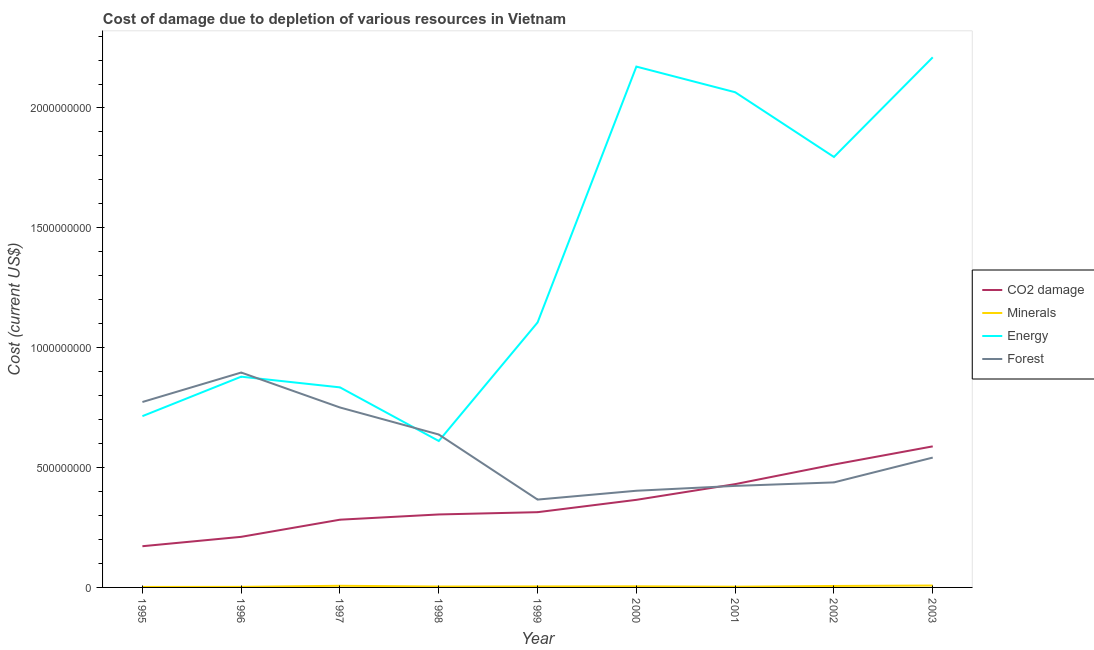How many different coloured lines are there?
Keep it short and to the point. 4. What is the cost of damage due to depletion of coal in 1999?
Offer a terse response. 3.14e+08. Across all years, what is the maximum cost of damage due to depletion of coal?
Your answer should be compact. 5.88e+08. Across all years, what is the minimum cost of damage due to depletion of forests?
Offer a very short reply. 3.66e+08. What is the total cost of damage due to depletion of energy in the graph?
Offer a very short reply. 1.24e+1. What is the difference between the cost of damage due to depletion of coal in 1996 and that in 1997?
Offer a terse response. -7.15e+07. What is the difference between the cost of damage due to depletion of forests in 1999 and the cost of damage due to depletion of energy in 2003?
Your answer should be compact. -1.84e+09. What is the average cost of damage due to depletion of forests per year?
Your answer should be compact. 5.81e+08. In the year 2003, what is the difference between the cost of damage due to depletion of minerals and cost of damage due to depletion of forests?
Your answer should be compact. -5.34e+08. In how many years, is the cost of damage due to depletion of coal greater than 800000000 US$?
Your answer should be very brief. 0. What is the ratio of the cost of damage due to depletion of coal in 2000 to that in 2001?
Keep it short and to the point. 0.85. What is the difference between the highest and the second highest cost of damage due to depletion of energy?
Offer a very short reply. 3.87e+07. What is the difference between the highest and the lowest cost of damage due to depletion of coal?
Ensure brevity in your answer.  4.17e+08. In how many years, is the cost of damage due to depletion of forests greater than the average cost of damage due to depletion of forests taken over all years?
Provide a succinct answer. 4. Is it the case that in every year, the sum of the cost of damage due to depletion of coal and cost of damage due to depletion of minerals is greater than the sum of cost of damage due to depletion of forests and cost of damage due to depletion of energy?
Your answer should be compact. No. Is the cost of damage due to depletion of forests strictly less than the cost of damage due to depletion of energy over the years?
Your answer should be very brief. No. How many lines are there?
Offer a terse response. 4. How many years are there in the graph?
Give a very brief answer. 9. What is the difference between two consecutive major ticks on the Y-axis?
Provide a short and direct response. 5.00e+08. How many legend labels are there?
Offer a terse response. 4. What is the title of the graph?
Ensure brevity in your answer.  Cost of damage due to depletion of various resources in Vietnam . What is the label or title of the Y-axis?
Give a very brief answer. Cost (current US$). What is the Cost (current US$) in CO2 damage in 1995?
Ensure brevity in your answer.  1.72e+08. What is the Cost (current US$) of Minerals in 1995?
Offer a terse response. 2.01e+06. What is the Cost (current US$) in Energy in 1995?
Offer a very short reply. 7.15e+08. What is the Cost (current US$) of Forest in 1995?
Give a very brief answer. 7.74e+08. What is the Cost (current US$) of CO2 damage in 1996?
Your answer should be compact. 2.11e+08. What is the Cost (current US$) in Minerals in 1996?
Provide a succinct answer. 2.35e+06. What is the Cost (current US$) of Energy in 1996?
Your response must be concise. 8.79e+08. What is the Cost (current US$) of Forest in 1996?
Your answer should be very brief. 8.96e+08. What is the Cost (current US$) in CO2 damage in 1997?
Offer a terse response. 2.83e+08. What is the Cost (current US$) of Minerals in 1997?
Ensure brevity in your answer.  6.86e+06. What is the Cost (current US$) of Energy in 1997?
Offer a terse response. 8.35e+08. What is the Cost (current US$) in Forest in 1997?
Keep it short and to the point. 7.51e+08. What is the Cost (current US$) of CO2 damage in 1998?
Offer a terse response. 3.04e+08. What is the Cost (current US$) in Minerals in 1998?
Your answer should be compact. 3.69e+06. What is the Cost (current US$) of Energy in 1998?
Offer a terse response. 6.11e+08. What is the Cost (current US$) in Forest in 1998?
Ensure brevity in your answer.  6.38e+08. What is the Cost (current US$) of CO2 damage in 1999?
Provide a short and direct response. 3.14e+08. What is the Cost (current US$) in Minerals in 1999?
Give a very brief answer. 4.13e+06. What is the Cost (current US$) of Energy in 1999?
Provide a short and direct response. 1.11e+09. What is the Cost (current US$) of Forest in 1999?
Your answer should be compact. 3.66e+08. What is the Cost (current US$) in CO2 damage in 2000?
Your answer should be compact. 3.65e+08. What is the Cost (current US$) of Minerals in 2000?
Your answer should be compact. 4.61e+06. What is the Cost (current US$) of Energy in 2000?
Provide a short and direct response. 2.17e+09. What is the Cost (current US$) of Forest in 2000?
Provide a short and direct response. 4.03e+08. What is the Cost (current US$) of CO2 damage in 2001?
Offer a terse response. 4.31e+08. What is the Cost (current US$) in Minerals in 2001?
Give a very brief answer. 3.05e+06. What is the Cost (current US$) in Energy in 2001?
Your answer should be compact. 2.07e+09. What is the Cost (current US$) in Forest in 2001?
Your response must be concise. 4.24e+08. What is the Cost (current US$) of CO2 damage in 2002?
Offer a terse response. 5.13e+08. What is the Cost (current US$) in Minerals in 2002?
Give a very brief answer. 6.10e+06. What is the Cost (current US$) in Energy in 2002?
Make the answer very short. 1.80e+09. What is the Cost (current US$) in Forest in 2002?
Provide a succinct answer. 4.38e+08. What is the Cost (current US$) in CO2 damage in 2003?
Your answer should be very brief. 5.88e+08. What is the Cost (current US$) of Minerals in 2003?
Your answer should be very brief. 7.88e+06. What is the Cost (current US$) in Energy in 2003?
Give a very brief answer. 2.21e+09. What is the Cost (current US$) of Forest in 2003?
Provide a short and direct response. 5.42e+08. Across all years, what is the maximum Cost (current US$) in CO2 damage?
Your response must be concise. 5.88e+08. Across all years, what is the maximum Cost (current US$) of Minerals?
Provide a short and direct response. 7.88e+06. Across all years, what is the maximum Cost (current US$) in Energy?
Keep it short and to the point. 2.21e+09. Across all years, what is the maximum Cost (current US$) in Forest?
Offer a very short reply. 8.96e+08. Across all years, what is the minimum Cost (current US$) of CO2 damage?
Your answer should be compact. 1.72e+08. Across all years, what is the minimum Cost (current US$) in Minerals?
Provide a short and direct response. 2.01e+06. Across all years, what is the minimum Cost (current US$) of Energy?
Offer a terse response. 6.11e+08. Across all years, what is the minimum Cost (current US$) in Forest?
Provide a succinct answer. 3.66e+08. What is the total Cost (current US$) of CO2 damage in the graph?
Make the answer very short. 3.18e+09. What is the total Cost (current US$) of Minerals in the graph?
Offer a terse response. 4.07e+07. What is the total Cost (current US$) of Energy in the graph?
Provide a succinct answer. 1.24e+1. What is the total Cost (current US$) of Forest in the graph?
Your answer should be very brief. 5.23e+09. What is the difference between the Cost (current US$) of CO2 damage in 1995 and that in 1996?
Your answer should be compact. -3.92e+07. What is the difference between the Cost (current US$) in Minerals in 1995 and that in 1996?
Your answer should be very brief. -3.38e+05. What is the difference between the Cost (current US$) of Energy in 1995 and that in 1996?
Provide a succinct answer. -1.65e+08. What is the difference between the Cost (current US$) of Forest in 1995 and that in 1996?
Give a very brief answer. -1.23e+08. What is the difference between the Cost (current US$) in CO2 damage in 1995 and that in 1997?
Your answer should be compact. -1.11e+08. What is the difference between the Cost (current US$) in Minerals in 1995 and that in 1997?
Your response must be concise. -4.85e+06. What is the difference between the Cost (current US$) of Energy in 1995 and that in 1997?
Make the answer very short. -1.20e+08. What is the difference between the Cost (current US$) in Forest in 1995 and that in 1997?
Ensure brevity in your answer.  2.29e+07. What is the difference between the Cost (current US$) of CO2 damage in 1995 and that in 1998?
Offer a very short reply. -1.33e+08. What is the difference between the Cost (current US$) in Minerals in 1995 and that in 1998?
Provide a short and direct response. -1.67e+06. What is the difference between the Cost (current US$) in Energy in 1995 and that in 1998?
Your response must be concise. 1.04e+08. What is the difference between the Cost (current US$) in Forest in 1995 and that in 1998?
Your response must be concise. 1.36e+08. What is the difference between the Cost (current US$) in CO2 damage in 1995 and that in 1999?
Your answer should be very brief. -1.42e+08. What is the difference between the Cost (current US$) in Minerals in 1995 and that in 1999?
Keep it short and to the point. -2.12e+06. What is the difference between the Cost (current US$) in Energy in 1995 and that in 1999?
Give a very brief answer. -3.91e+08. What is the difference between the Cost (current US$) in Forest in 1995 and that in 1999?
Offer a terse response. 4.07e+08. What is the difference between the Cost (current US$) in CO2 damage in 1995 and that in 2000?
Ensure brevity in your answer.  -1.93e+08. What is the difference between the Cost (current US$) of Minerals in 1995 and that in 2000?
Keep it short and to the point. -2.59e+06. What is the difference between the Cost (current US$) of Energy in 1995 and that in 2000?
Offer a very short reply. -1.46e+09. What is the difference between the Cost (current US$) in Forest in 1995 and that in 2000?
Keep it short and to the point. 3.70e+08. What is the difference between the Cost (current US$) of CO2 damage in 1995 and that in 2001?
Ensure brevity in your answer.  -2.59e+08. What is the difference between the Cost (current US$) in Minerals in 1995 and that in 2001?
Your answer should be very brief. -1.03e+06. What is the difference between the Cost (current US$) in Energy in 1995 and that in 2001?
Offer a very short reply. -1.35e+09. What is the difference between the Cost (current US$) in Forest in 1995 and that in 2001?
Offer a terse response. 3.50e+08. What is the difference between the Cost (current US$) in CO2 damage in 1995 and that in 2002?
Your answer should be compact. -3.41e+08. What is the difference between the Cost (current US$) in Minerals in 1995 and that in 2002?
Provide a succinct answer. -4.08e+06. What is the difference between the Cost (current US$) of Energy in 1995 and that in 2002?
Make the answer very short. -1.08e+09. What is the difference between the Cost (current US$) in Forest in 1995 and that in 2002?
Make the answer very short. 3.35e+08. What is the difference between the Cost (current US$) in CO2 damage in 1995 and that in 2003?
Your answer should be compact. -4.17e+08. What is the difference between the Cost (current US$) of Minerals in 1995 and that in 2003?
Offer a very short reply. -5.86e+06. What is the difference between the Cost (current US$) in Energy in 1995 and that in 2003?
Your answer should be compact. -1.50e+09. What is the difference between the Cost (current US$) in Forest in 1995 and that in 2003?
Keep it short and to the point. 2.32e+08. What is the difference between the Cost (current US$) of CO2 damage in 1996 and that in 1997?
Your answer should be very brief. -7.15e+07. What is the difference between the Cost (current US$) in Minerals in 1996 and that in 1997?
Ensure brevity in your answer.  -4.51e+06. What is the difference between the Cost (current US$) of Energy in 1996 and that in 1997?
Your answer should be compact. 4.46e+07. What is the difference between the Cost (current US$) in Forest in 1996 and that in 1997?
Your answer should be compact. 1.46e+08. What is the difference between the Cost (current US$) of CO2 damage in 1996 and that in 1998?
Provide a short and direct response. -9.34e+07. What is the difference between the Cost (current US$) in Minerals in 1996 and that in 1998?
Your answer should be very brief. -1.33e+06. What is the difference between the Cost (current US$) of Energy in 1996 and that in 1998?
Your answer should be very brief. 2.68e+08. What is the difference between the Cost (current US$) of Forest in 1996 and that in 1998?
Offer a terse response. 2.59e+08. What is the difference between the Cost (current US$) in CO2 damage in 1996 and that in 1999?
Make the answer very short. -1.03e+08. What is the difference between the Cost (current US$) of Minerals in 1996 and that in 1999?
Keep it short and to the point. -1.78e+06. What is the difference between the Cost (current US$) of Energy in 1996 and that in 1999?
Provide a succinct answer. -2.26e+08. What is the difference between the Cost (current US$) of Forest in 1996 and that in 1999?
Give a very brief answer. 5.30e+08. What is the difference between the Cost (current US$) of CO2 damage in 1996 and that in 2000?
Ensure brevity in your answer.  -1.54e+08. What is the difference between the Cost (current US$) in Minerals in 1996 and that in 2000?
Make the answer very short. -2.25e+06. What is the difference between the Cost (current US$) of Energy in 1996 and that in 2000?
Offer a terse response. -1.29e+09. What is the difference between the Cost (current US$) in Forest in 1996 and that in 2000?
Give a very brief answer. 4.93e+08. What is the difference between the Cost (current US$) of CO2 damage in 1996 and that in 2001?
Provide a short and direct response. -2.20e+08. What is the difference between the Cost (current US$) in Minerals in 1996 and that in 2001?
Give a very brief answer. -6.95e+05. What is the difference between the Cost (current US$) of Energy in 1996 and that in 2001?
Your response must be concise. -1.19e+09. What is the difference between the Cost (current US$) in Forest in 1996 and that in 2001?
Your answer should be compact. 4.73e+08. What is the difference between the Cost (current US$) in CO2 damage in 1996 and that in 2002?
Ensure brevity in your answer.  -3.02e+08. What is the difference between the Cost (current US$) of Minerals in 1996 and that in 2002?
Offer a terse response. -3.75e+06. What is the difference between the Cost (current US$) of Energy in 1996 and that in 2002?
Ensure brevity in your answer.  -9.17e+08. What is the difference between the Cost (current US$) of Forest in 1996 and that in 2002?
Provide a succinct answer. 4.58e+08. What is the difference between the Cost (current US$) of CO2 damage in 1996 and that in 2003?
Offer a terse response. -3.77e+08. What is the difference between the Cost (current US$) of Minerals in 1996 and that in 2003?
Your response must be concise. -5.53e+06. What is the difference between the Cost (current US$) in Energy in 1996 and that in 2003?
Keep it short and to the point. -1.33e+09. What is the difference between the Cost (current US$) in Forest in 1996 and that in 2003?
Offer a very short reply. 3.55e+08. What is the difference between the Cost (current US$) of CO2 damage in 1997 and that in 1998?
Offer a terse response. -2.19e+07. What is the difference between the Cost (current US$) in Minerals in 1997 and that in 1998?
Offer a very short reply. 3.17e+06. What is the difference between the Cost (current US$) in Energy in 1997 and that in 1998?
Your response must be concise. 2.24e+08. What is the difference between the Cost (current US$) of Forest in 1997 and that in 1998?
Your response must be concise. 1.13e+08. What is the difference between the Cost (current US$) in CO2 damage in 1997 and that in 1999?
Your answer should be compact. -3.14e+07. What is the difference between the Cost (current US$) in Minerals in 1997 and that in 1999?
Your answer should be compact. 2.73e+06. What is the difference between the Cost (current US$) in Energy in 1997 and that in 1999?
Make the answer very short. -2.71e+08. What is the difference between the Cost (current US$) in Forest in 1997 and that in 1999?
Ensure brevity in your answer.  3.84e+08. What is the difference between the Cost (current US$) in CO2 damage in 1997 and that in 2000?
Keep it short and to the point. -8.28e+07. What is the difference between the Cost (current US$) in Minerals in 1997 and that in 2000?
Provide a succinct answer. 2.26e+06. What is the difference between the Cost (current US$) of Energy in 1997 and that in 2000?
Ensure brevity in your answer.  -1.34e+09. What is the difference between the Cost (current US$) of Forest in 1997 and that in 2000?
Your answer should be very brief. 3.47e+08. What is the difference between the Cost (current US$) in CO2 damage in 1997 and that in 2001?
Ensure brevity in your answer.  -1.48e+08. What is the difference between the Cost (current US$) of Minerals in 1997 and that in 2001?
Offer a terse response. 3.81e+06. What is the difference between the Cost (current US$) in Energy in 1997 and that in 2001?
Provide a short and direct response. -1.23e+09. What is the difference between the Cost (current US$) in Forest in 1997 and that in 2001?
Your response must be concise. 3.27e+08. What is the difference between the Cost (current US$) of CO2 damage in 1997 and that in 2002?
Offer a very short reply. -2.30e+08. What is the difference between the Cost (current US$) in Minerals in 1997 and that in 2002?
Your answer should be compact. 7.62e+05. What is the difference between the Cost (current US$) of Energy in 1997 and that in 2002?
Provide a short and direct response. -9.61e+08. What is the difference between the Cost (current US$) in Forest in 1997 and that in 2002?
Your response must be concise. 3.12e+08. What is the difference between the Cost (current US$) of CO2 damage in 1997 and that in 2003?
Offer a terse response. -3.06e+08. What is the difference between the Cost (current US$) in Minerals in 1997 and that in 2003?
Offer a terse response. -1.02e+06. What is the difference between the Cost (current US$) in Energy in 1997 and that in 2003?
Offer a terse response. -1.38e+09. What is the difference between the Cost (current US$) of Forest in 1997 and that in 2003?
Offer a very short reply. 2.09e+08. What is the difference between the Cost (current US$) in CO2 damage in 1998 and that in 1999?
Provide a short and direct response. -9.47e+06. What is the difference between the Cost (current US$) of Minerals in 1998 and that in 1999?
Make the answer very short. -4.44e+05. What is the difference between the Cost (current US$) in Energy in 1998 and that in 1999?
Provide a succinct answer. -4.94e+08. What is the difference between the Cost (current US$) of Forest in 1998 and that in 1999?
Ensure brevity in your answer.  2.71e+08. What is the difference between the Cost (current US$) in CO2 damage in 1998 and that in 2000?
Provide a short and direct response. -6.09e+07. What is the difference between the Cost (current US$) in Minerals in 1998 and that in 2000?
Make the answer very short. -9.19e+05. What is the difference between the Cost (current US$) of Energy in 1998 and that in 2000?
Offer a very short reply. -1.56e+09. What is the difference between the Cost (current US$) in Forest in 1998 and that in 2000?
Provide a succinct answer. 2.35e+08. What is the difference between the Cost (current US$) of CO2 damage in 1998 and that in 2001?
Offer a terse response. -1.26e+08. What is the difference between the Cost (current US$) in Minerals in 1998 and that in 2001?
Offer a terse response. 6.39e+05. What is the difference between the Cost (current US$) of Energy in 1998 and that in 2001?
Keep it short and to the point. -1.45e+09. What is the difference between the Cost (current US$) of Forest in 1998 and that in 2001?
Make the answer very short. 2.14e+08. What is the difference between the Cost (current US$) of CO2 damage in 1998 and that in 2002?
Keep it short and to the point. -2.08e+08. What is the difference between the Cost (current US$) of Minerals in 1998 and that in 2002?
Offer a very short reply. -2.41e+06. What is the difference between the Cost (current US$) of Energy in 1998 and that in 2002?
Make the answer very short. -1.18e+09. What is the difference between the Cost (current US$) in Forest in 1998 and that in 2002?
Offer a very short reply. 2.00e+08. What is the difference between the Cost (current US$) in CO2 damage in 1998 and that in 2003?
Keep it short and to the point. -2.84e+08. What is the difference between the Cost (current US$) in Minerals in 1998 and that in 2003?
Ensure brevity in your answer.  -4.19e+06. What is the difference between the Cost (current US$) in Energy in 1998 and that in 2003?
Provide a succinct answer. -1.60e+09. What is the difference between the Cost (current US$) of Forest in 1998 and that in 2003?
Offer a terse response. 9.62e+07. What is the difference between the Cost (current US$) of CO2 damage in 1999 and that in 2000?
Your answer should be compact. -5.15e+07. What is the difference between the Cost (current US$) in Minerals in 1999 and that in 2000?
Your answer should be very brief. -4.75e+05. What is the difference between the Cost (current US$) of Energy in 1999 and that in 2000?
Your answer should be very brief. -1.07e+09. What is the difference between the Cost (current US$) in Forest in 1999 and that in 2000?
Offer a terse response. -3.68e+07. What is the difference between the Cost (current US$) of CO2 damage in 1999 and that in 2001?
Ensure brevity in your answer.  -1.17e+08. What is the difference between the Cost (current US$) in Minerals in 1999 and that in 2001?
Ensure brevity in your answer.  1.08e+06. What is the difference between the Cost (current US$) in Energy in 1999 and that in 2001?
Provide a short and direct response. -9.60e+08. What is the difference between the Cost (current US$) in Forest in 1999 and that in 2001?
Your response must be concise. -5.71e+07. What is the difference between the Cost (current US$) of CO2 damage in 1999 and that in 2002?
Your response must be concise. -1.99e+08. What is the difference between the Cost (current US$) of Minerals in 1999 and that in 2002?
Provide a short and direct response. -1.97e+06. What is the difference between the Cost (current US$) in Energy in 1999 and that in 2002?
Your answer should be compact. -6.90e+08. What is the difference between the Cost (current US$) of Forest in 1999 and that in 2002?
Provide a succinct answer. -7.17e+07. What is the difference between the Cost (current US$) in CO2 damage in 1999 and that in 2003?
Provide a short and direct response. -2.75e+08. What is the difference between the Cost (current US$) of Minerals in 1999 and that in 2003?
Your answer should be compact. -3.75e+06. What is the difference between the Cost (current US$) in Energy in 1999 and that in 2003?
Provide a short and direct response. -1.11e+09. What is the difference between the Cost (current US$) in Forest in 1999 and that in 2003?
Offer a very short reply. -1.75e+08. What is the difference between the Cost (current US$) of CO2 damage in 2000 and that in 2001?
Provide a short and direct response. -6.55e+07. What is the difference between the Cost (current US$) in Minerals in 2000 and that in 2001?
Your answer should be very brief. 1.56e+06. What is the difference between the Cost (current US$) of Energy in 2000 and that in 2001?
Your answer should be compact. 1.07e+08. What is the difference between the Cost (current US$) in Forest in 2000 and that in 2001?
Ensure brevity in your answer.  -2.03e+07. What is the difference between the Cost (current US$) in CO2 damage in 2000 and that in 2002?
Offer a terse response. -1.47e+08. What is the difference between the Cost (current US$) in Minerals in 2000 and that in 2002?
Keep it short and to the point. -1.49e+06. What is the difference between the Cost (current US$) in Energy in 2000 and that in 2002?
Your answer should be very brief. 3.77e+08. What is the difference between the Cost (current US$) in Forest in 2000 and that in 2002?
Provide a succinct answer. -3.49e+07. What is the difference between the Cost (current US$) in CO2 damage in 2000 and that in 2003?
Ensure brevity in your answer.  -2.23e+08. What is the difference between the Cost (current US$) in Minerals in 2000 and that in 2003?
Your answer should be compact. -3.27e+06. What is the difference between the Cost (current US$) of Energy in 2000 and that in 2003?
Give a very brief answer. -3.87e+07. What is the difference between the Cost (current US$) of Forest in 2000 and that in 2003?
Ensure brevity in your answer.  -1.38e+08. What is the difference between the Cost (current US$) in CO2 damage in 2001 and that in 2002?
Your answer should be compact. -8.17e+07. What is the difference between the Cost (current US$) in Minerals in 2001 and that in 2002?
Your response must be concise. -3.05e+06. What is the difference between the Cost (current US$) in Energy in 2001 and that in 2002?
Provide a succinct answer. 2.70e+08. What is the difference between the Cost (current US$) in Forest in 2001 and that in 2002?
Make the answer very short. -1.46e+07. What is the difference between the Cost (current US$) of CO2 damage in 2001 and that in 2003?
Your response must be concise. -1.58e+08. What is the difference between the Cost (current US$) of Minerals in 2001 and that in 2003?
Ensure brevity in your answer.  -4.83e+06. What is the difference between the Cost (current US$) in Energy in 2001 and that in 2003?
Offer a terse response. -1.46e+08. What is the difference between the Cost (current US$) of Forest in 2001 and that in 2003?
Give a very brief answer. -1.18e+08. What is the difference between the Cost (current US$) in CO2 damage in 2002 and that in 2003?
Your response must be concise. -7.58e+07. What is the difference between the Cost (current US$) of Minerals in 2002 and that in 2003?
Offer a very short reply. -1.78e+06. What is the difference between the Cost (current US$) in Energy in 2002 and that in 2003?
Make the answer very short. -4.16e+08. What is the difference between the Cost (current US$) in Forest in 2002 and that in 2003?
Your answer should be compact. -1.04e+08. What is the difference between the Cost (current US$) in CO2 damage in 1995 and the Cost (current US$) in Minerals in 1996?
Keep it short and to the point. 1.70e+08. What is the difference between the Cost (current US$) of CO2 damage in 1995 and the Cost (current US$) of Energy in 1996?
Keep it short and to the point. -7.07e+08. What is the difference between the Cost (current US$) of CO2 damage in 1995 and the Cost (current US$) of Forest in 1996?
Provide a succinct answer. -7.25e+08. What is the difference between the Cost (current US$) of Minerals in 1995 and the Cost (current US$) of Energy in 1996?
Make the answer very short. -8.77e+08. What is the difference between the Cost (current US$) of Minerals in 1995 and the Cost (current US$) of Forest in 1996?
Offer a terse response. -8.94e+08. What is the difference between the Cost (current US$) in Energy in 1995 and the Cost (current US$) in Forest in 1996?
Ensure brevity in your answer.  -1.82e+08. What is the difference between the Cost (current US$) of CO2 damage in 1995 and the Cost (current US$) of Minerals in 1997?
Your answer should be very brief. 1.65e+08. What is the difference between the Cost (current US$) of CO2 damage in 1995 and the Cost (current US$) of Energy in 1997?
Give a very brief answer. -6.63e+08. What is the difference between the Cost (current US$) in CO2 damage in 1995 and the Cost (current US$) in Forest in 1997?
Keep it short and to the point. -5.79e+08. What is the difference between the Cost (current US$) of Minerals in 1995 and the Cost (current US$) of Energy in 1997?
Your answer should be compact. -8.32e+08. What is the difference between the Cost (current US$) of Minerals in 1995 and the Cost (current US$) of Forest in 1997?
Give a very brief answer. -7.49e+08. What is the difference between the Cost (current US$) in Energy in 1995 and the Cost (current US$) in Forest in 1997?
Ensure brevity in your answer.  -3.61e+07. What is the difference between the Cost (current US$) of CO2 damage in 1995 and the Cost (current US$) of Minerals in 1998?
Your answer should be compact. 1.68e+08. What is the difference between the Cost (current US$) of CO2 damage in 1995 and the Cost (current US$) of Energy in 1998?
Keep it short and to the point. -4.39e+08. What is the difference between the Cost (current US$) in CO2 damage in 1995 and the Cost (current US$) in Forest in 1998?
Provide a short and direct response. -4.66e+08. What is the difference between the Cost (current US$) in Minerals in 1995 and the Cost (current US$) in Energy in 1998?
Give a very brief answer. -6.09e+08. What is the difference between the Cost (current US$) in Minerals in 1995 and the Cost (current US$) in Forest in 1998?
Make the answer very short. -6.36e+08. What is the difference between the Cost (current US$) in Energy in 1995 and the Cost (current US$) in Forest in 1998?
Provide a succinct answer. 7.66e+07. What is the difference between the Cost (current US$) of CO2 damage in 1995 and the Cost (current US$) of Minerals in 1999?
Your answer should be compact. 1.68e+08. What is the difference between the Cost (current US$) of CO2 damage in 1995 and the Cost (current US$) of Energy in 1999?
Make the answer very short. -9.33e+08. What is the difference between the Cost (current US$) in CO2 damage in 1995 and the Cost (current US$) in Forest in 1999?
Your answer should be very brief. -1.95e+08. What is the difference between the Cost (current US$) of Minerals in 1995 and the Cost (current US$) of Energy in 1999?
Offer a terse response. -1.10e+09. What is the difference between the Cost (current US$) in Minerals in 1995 and the Cost (current US$) in Forest in 1999?
Your response must be concise. -3.64e+08. What is the difference between the Cost (current US$) in Energy in 1995 and the Cost (current US$) in Forest in 1999?
Ensure brevity in your answer.  3.48e+08. What is the difference between the Cost (current US$) of CO2 damage in 1995 and the Cost (current US$) of Minerals in 2000?
Give a very brief answer. 1.67e+08. What is the difference between the Cost (current US$) in CO2 damage in 1995 and the Cost (current US$) in Energy in 2000?
Ensure brevity in your answer.  -2.00e+09. What is the difference between the Cost (current US$) of CO2 damage in 1995 and the Cost (current US$) of Forest in 2000?
Your answer should be very brief. -2.31e+08. What is the difference between the Cost (current US$) of Minerals in 1995 and the Cost (current US$) of Energy in 2000?
Keep it short and to the point. -2.17e+09. What is the difference between the Cost (current US$) in Minerals in 1995 and the Cost (current US$) in Forest in 2000?
Provide a succinct answer. -4.01e+08. What is the difference between the Cost (current US$) in Energy in 1995 and the Cost (current US$) in Forest in 2000?
Keep it short and to the point. 3.11e+08. What is the difference between the Cost (current US$) of CO2 damage in 1995 and the Cost (current US$) of Minerals in 2001?
Give a very brief answer. 1.69e+08. What is the difference between the Cost (current US$) of CO2 damage in 1995 and the Cost (current US$) of Energy in 2001?
Offer a terse response. -1.89e+09. What is the difference between the Cost (current US$) in CO2 damage in 1995 and the Cost (current US$) in Forest in 2001?
Make the answer very short. -2.52e+08. What is the difference between the Cost (current US$) of Minerals in 1995 and the Cost (current US$) of Energy in 2001?
Offer a very short reply. -2.06e+09. What is the difference between the Cost (current US$) of Minerals in 1995 and the Cost (current US$) of Forest in 2001?
Make the answer very short. -4.22e+08. What is the difference between the Cost (current US$) of Energy in 1995 and the Cost (current US$) of Forest in 2001?
Your response must be concise. 2.91e+08. What is the difference between the Cost (current US$) of CO2 damage in 1995 and the Cost (current US$) of Minerals in 2002?
Provide a short and direct response. 1.66e+08. What is the difference between the Cost (current US$) of CO2 damage in 1995 and the Cost (current US$) of Energy in 2002?
Provide a succinct answer. -1.62e+09. What is the difference between the Cost (current US$) in CO2 damage in 1995 and the Cost (current US$) in Forest in 2002?
Ensure brevity in your answer.  -2.66e+08. What is the difference between the Cost (current US$) in Minerals in 1995 and the Cost (current US$) in Energy in 2002?
Provide a succinct answer. -1.79e+09. What is the difference between the Cost (current US$) in Minerals in 1995 and the Cost (current US$) in Forest in 2002?
Offer a very short reply. -4.36e+08. What is the difference between the Cost (current US$) in Energy in 1995 and the Cost (current US$) in Forest in 2002?
Keep it short and to the point. 2.76e+08. What is the difference between the Cost (current US$) of CO2 damage in 1995 and the Cost (current US$) of Minerals in 2003?
Give a very brief answer. 1.64e+08. What is the difference between the Cost (current US$) in CO2 damage in 1995 and the Cost (current US$) in Energy in 2003?
Offer a terse response. -2.04e+09. What is the difference between the Cost (current US$) of CO2 damage in 1995 and the Cost (current US$) of Forest in 2003?
Keep it short and to the point. -3.70e+08. What is the difference between the Cost (current US$) in Minerals in 1995 and the Cost (current US$) in Energy in 2003?
Offer a very short reply. -2.21e+09. What is the difference between the Cost (current US$) of Minerals in 1995 and the Cost (current US$) of Forest in 2003?
Keep it short and to the point. -5.40e+08. What is the difference between the Cost (current US$) in Energy in 1995 and the Cost (current US$) in Forest in 2003?
Make the answer very short. 1.73e+08. What is the difference between the Cost (current US$) of CO2 damage in 1996 and the Cost (current US$) of Minerals in 1997?
Make the answer very short. 2.04e+08. What is the difference between the Cost (current US$) in CO2 damage in 1996 and the Cost (current US$) in Energy in 1997?
Offer a terse response. -6.23e+08. What is the difference between the Cost (current US$) of CO2 damage in 1996 and the Cost (current US$) of Forest in 1997?
Provide a succinct answer. -5.40e+08. What is the difference between the Cost (current US$) of Minerals in 1996 and the Cost (current US$) of Energy in 1997?
Make the answer very short. -8.32e+08. What is the difference between the Cost (current US$) in Minerals in 1996 and the Cost (current US$) in Forest in 1997?
Make the answer very short. -7.48e+08. What is the difference between the Cost (current US$) of Energy in 1996 and the Cost (current US$) of Forest in 1997?
Offer a very short reply. 1.29e+08. What is the difference between the Cost (current US$) in CO2 damage in 1996 and the Cost (current US$) in Minerals in 1998?
Provide a succinct answer. 2.07e+08. What is the difference between the Cost (current US$) of CO2 damage in 1996 and the Cost (current US$) of Energy in 1998?
Your answer should be compact. -4.00e+08. What is the difference between the Cost (current US$) of CO2 damage in 1996 and the Cost (current US$) of Forest in 1998?
Offer a very short reply. -4.27e+08. What is the difference between the Cost (current US$) in Minerals in 1996 and the Cost (current US$) in Energy in 1998?
Make the answer very short. -6.08e+08. What is the difference between the Cost (current US$) of Minerals in 1996 and the Cost (current US$) of Forest in 1998?
Offer a very short reply. -6.36e+08. What is the difference between the Cost (current US$) in Energy in 1996 and the Cost (current US$) in Forest in 1998?
Offer a terse response. 2.41e+08. What is the difference between the Cost (current US$) in CO2 damage in 1996 and the Cost (current US$) in Minerals in 1999?
Provide a short and direct response. 2.07e+08. What is the difference between the Cost (current US$) of CO2 damage in 1996 and the Cost (current US$) of Energy in 1999?
Make the answer very short. -8.94e+08. What is the difference between the Cost (current US$) in CO2 damage in 1996 and the Cost (current US$) in Forest in 1999?
Offer a very short reply. -1.55e+08. What is the difference between the Cost (current US$) of Minerals in 1996 and the Cost (current US$) of Energy in 1999?
Provide a succinct answer. -1.10e+09. What is the difference between the Cost (current US$) of Minerals in 1996 and the Cost (current US$) of Forest in 1999?
Give a very brief answer. -3.64e+08. What is the difference between the Cost (current US$) of Energy in 1996 and the Cost (current US$) of Forest in 1999?
Offer a very short reply. 5.13e+08. What is the difference between the Cost (current US$) in CO2 damage in 1996 and the Cost (current US$) in Minerals in 2000?
Offer a terse response. 2.06e+08. What is the difference between the Cost (current US$) in CO2 damage in 1996 and the Cost (current US$) in Energy in 2000?
Offer a terse response. -1.96e+09. What is the difference between the Cost (current US$) in CO2 damage in 1996 and the Cost (current US$) in Forest in 2000?
Give a very brief answer. -1.92e+08. What is the difference between the Cost (current US$) of Minerals in 1996 and the Cost (current US$) of Energy in 2000?
Ensure brevity in your answer.  -2.17e+09. What is the difference between the Cost (current US$) in Minerals in 1996 and the Cost (current US$) in Forest in 2000?
Make the answer very short. -4.01e+08. What is the difference between the Cost (current US$) in Energy in 1996 and the Cost (current US$) in Forest in 2000?
Keep it short and to the point. 4.76e+08. What is the difference between the Cost (current US$) in CO2 damage in 1996 and the Cost (current US$) in Minerals in 2001?
Make the answer very short. 2.08e+08. What is the difference between the Cost (current US$) in CO2 damage in 1996 and the Cost (current US$) in Energy in 2001?
Ensure brevity in your answer.  -1.85e+09. What is the difference between the Cost (current US$) of CO2 damage in 1996 and the Cost (current US$) of Forest in 2001?
Your answer should be compact. -2.13e+08. What is the difference between the Cost (current US$) of Minerals in 1996 and the Cost (current US$) of Energy in 2001?
Provide a succinct answer. -2.06e+09. What is the difference between the Cost (current US$) in Minerals in 1996 and the Cost (current US$) in Forest in 2001?
Ensure brevity in your answer.  -4.21e+08. What is the difference between the Cost (current US$) in Energy in 1996 and the Cost (current US$) in Forest in 2001?
Provide a short and direct response. 4.56e+08. What is the difference between the Cost (current US$) of CO2 damage in 1996 and the Cost (current US$) of Minerals in 2002?
Provide a short and direct response. 2.05e+08. What is the difference between the Cost (current US$) of CO2 damage in 1996 and the Cost (current US$) of Energy in 2002?
Ensure brevity in your answer.  -1.58e+09. What is the difference between the Cost (current US$) of CO2 damage in 1996 and the Cost (current US$) of Forest in 2002?
Make the answer very short. -2.27e+08. What is the difference between the Cost (current US$) in Minerals in 1996 and the Cost (current US$) in Energy in 2002?
Keep it short and to the point. -1.79e+09. What is the difference between the Cost (current US$) in Minerals in 1996 and the Cost (current US$) in Forest in 2002?
Your response must be concise. -4.36e+08. What is the difference between the Cost (current US$) of Energy in 1996 and the Cost (current US$) of Forest in 2002?
Keep it short and to the point. 4.41e+08. What is the difference between the Cost (current US$) of CO2 damage in 1996 and the Cost (current US$) of Minerals in 2003?
Your answer should be compact. 2.03e+08. What is the difference between the Cost (current US$) in CO2 damage in 1996 and the Cost (current US$) in Energy in 2003?
Offer a very short reply. -2.00e+09. What is the difference between the Cost (current US$) of CO2 damage in 1996 and the Cost (current US$) of Forest in 2003?
Your answer should be very brief. -3.31e+08. What is the difference between the Cost (current US$) in Minerals in 1996 and the Cost (current US$) in Energy in 2003?
Offer a terse response. -2.21e+09. What is the difference between the Cost (current US$) of Minerals in 1996 and the Cost (current US$) of Forest in 2003?
Offer a very short reply. -5.39e+08. What is the difference between the Cost (current US$) of Energy in 1996 and the Cost (current US$) of Forest in 2003?
Your answer should be compact. 3.37e+08. What is the difference between the Cost (current US$) in CO2 damage in 1997 and the Cost (current US$) in Minerals in 1998?
Your answer should be compact. 2.79e+08. What is the difference between the Cost (current US$) of CO2 damage in 1997 and the Cost (current US$) of Energy in 1998?
Your answer should be very brief. -3.28e+08. What is the difference between the Cost (current US$) of CO2 damage in 1997 and the Cost (current US$) of Forest in 1998?
Provide a succinct answer. -3.55e+08. What is the difference between the Cost (current US$) in Minerals in 1997 and the Cost (current US$) in Energy in 1998?
Give a very brief answer. -6.04e+08. What is the difference between the Cost (current US$) in Minerals in 1997 and the Cost (current US$) in Forest in 1998?
Ensure brevity in your answer.  -6.31e+08. What is the difference between the Cost (current US$) of Energy in 1997 and the Cost (current US$) of Forest in 1998?
Your response must be concise. 1.97e+08. What is the difference between the Cost (current US$) of CO2 damage in 1997 and the Cost (current US$) of Minerals in 1999?
Provide a succinct answer. 2.78e+08. What is the difference between the Cost (current US$) of CO2 damage in 1997 and the Cost (current US$) of Energy in 1999?
Your answer should be compact. -8.23e+08. What is the difference between the Cost (current US$) in CO2 damage in 1997 and the Cost (current US$) in Forest in 1999?
Keep it short and to the point. -8.39e+07. What is the difference between the Cost (current US$) in Minerals in 1997 and the Cost (current US$) in Energy in 1999?
Offer a very short reply. -1.10e+09. What is the difference between the Cost (current US$) in Minerals in 1997 and the Cost (current US$) in Forest in 1999?
Give a very brief answer. -3.60e+08. What is the difference between the Cost (current US$) in Energy in 1997 and the Cost (current US$) in Forest in 1999?
Provide a succinct answer. 4.68e+08. What is the difference between the Cost (current US$) in CO2 damage in 1997 and the Cost (current US$) in Minerals in 2000?
Offer a very short reply. 2.78e+08. What is the difference between the Cost (current US$) of CO2 damage in 1997 and the Cost (current US$) of Energy in 2000?
Give a very brief answer. -1.89e+09. What is the difference between the Cost (current US$) in CO2 damage in 1997 and the Cost (current US$) in Forest in 2000?
Your response must be concise. -1.21e+08. What is the difference between the Cost (current US$) of Minerals in 1997 and the Cost (current US$) of Energy in 2000?
Give a very brief answer. -2.17e+09. What is the difference between the Cost (current US$) of Minerals in 1997 and the Cost (current US$) of Forest in 2000?
Keep it short and to the point. -3.96e+08. What is the difference between the Cost (current US$) in Energy in 1997 and the Cost (current US$) in Forest in 2000?
Offer a very short reply. 4.31e+08. What is the difference between the Cost (current US$) in CO2 damage in 1997 and the Cost (current US$) in Minerals in 2001?
Ensure brevity in your answer.  2.80e+08. What is the difference between the Cost (current US$) of CO2 damage in 1997 and the Cost (current US$) of Energy in 2001?
Make the answer very short. -1.78e+09. What is the difference between the Cost (current US$) in CO2 damage in 1997 and the Cost (current US$) in Forest in 2001?
Your response must be concise. -1.41e+08. What is the difference between the Cost (current US$) in Minerals in 1997 and the Cost (current US$) in Energy in 2001?
Offer a very short reply. -2.06e+09. What is the difference between the Cost (current US$) of Minerals in 1997 and the Cost (current US$) of Forest in 2001?
Your answer should be compact. -4.17e+08. What is the difference between the Cost (current US$) of Energy in 1997 and the Cost (current US$) of Forest in 2001?
Your answer should be very brief. 4.11e+08. What is the difference between the Cost (current US$) of CO2 damage in 1997 and the Cost (current US$) of Minerals in 2002?
Ensure brevity in your answer.  2.76e+08. What is the difference between the Cost (current US$) of CO2 damage in 1997 and the Cost (current US$) of Energy in 2002?
Offer a very short reply. -1.51e+09. What is the difference between the Cost (current US$) in CO2 damage in 1997 and the Cost (current US$) in Forest in 2002?
Provide a succinct answer. -1.56e+08. What is the difference between the Cost (current US$) in Minerals in 1997 and the Cost (current US$) in Energy in 2002?
Your answer should be compact. -1.79e+09. What is the difference between the Cost (current US$) in Minerals in 1997 and the Cost (current US$) in Forest in 2002?
Your response must be concise. -4.31e+08. What is the difference between the Cost (current US$) of Energy in 1997 and the Cost (current US$) of Forest in 2002?
Your answer should be compact. 3.96e+08. What is the difference between the Cost (current US$) in CO2 damage in 1997 and the Cost (current US$) in Minerals in 2003?
Provide a short and direct response. 2.75e+08. What is the difference between the Cost (current US$) of CO2 damage in 1997 and the Cost (current US$) of Energy in 2003?
Offer a very short reply. -1.93e+09. What is the difference between the Cost (current US$) in CO2 damage in 1997 and the Cost (current US$) in Forest in 2003?
Your answer should be very brief. -2.59e+08. What is the difference between the Cost (current US$) in Minerals in 1997 and the Cost (current US$) in Energy in 2003?
Keep it short and to the point. -2.20e+09. What is the difference between the Cost (current US$) of Minerals in 1997 and the Cost (current US$) of Forest in 2003?
Make the answer very short. -5.35e+08. What is the difference between the Cost (current US$) in Energy in 1997 and the Cost (current US$) in Forest in 2003?
Your response must be concise. 2.93e+08. What is the difference between the Cost (current US$) of CO2 damage in 1998 and the Cost (current US$) of Minerals in 1999?
Make the answer very short. 3.00e+08. What is the difference between the Cost (current US$) in CO2 damage in 1998 and the Cost (current US$) in Energy in 1999?
Provide a short and direct response. -8.01e+08. What is the difference between the Cost (current US$) in CO2 damage in 1998 and the Cost (current US$) in Forest in 1999?
Ensure brevity in your answer.  -6.20e+07. What is the difference between the Cost (current US$) of Minerals in 1998 and the Cost (current US$) of Energy in 1999?
Provide a succinct answer. -1.10e+09. What is the difference between the Cost (current US$) in Minerals in 1998 and the Cost (current US$) in Forest in 1999?
Give a very brief answer. -3.63e+08. What is the difference between the Cost (current US$) in Energy in 1998 and the Cost (current US$) in Forest in 1999?
Keep it short and to the point. 2.44e+08. What is the difference between the Cost (current US$) in CO2 damage in 1998 and the Cost (current US$) in Minerals in 2000?
Give a very brief answer. 3.00e+08. What is the difference between the Cost (current US$) of CO2 damage in 1998 and the Cost (current US$) of Energy in 2000?
Provide a succinct answer. -1.87e+09. What is the difference between the Cost (current US$) of CO2 damage in 1998 and the Cost (current US$) of Forest in 2000?
Keep it short and to the point. -9.88e+07. What is the difference between the Cost (current US$) of Minerals in 1998 and the Cost (current US$) of Energy in 2000?
Offer a very short reply. -2.17e+09. What is the difference between the Cost (current US$) in Minerals in 1998 and the Cost (current US$) in Forest in 2000?
Offer a very short reply. -4.00e+08. What is the difference between the Cost (current US$) of Energy in 1998 and the Cost (current US$) of Forest in 2000?
Give a very brief answer. 2.08e+08. What is the difference between the Cost (current US$) of CO2 damage in 1998 and the Cost (current US$) of Minerals in 2001?
Provide a succinct answer. 3.01e+08. What is the difference between the Cost (current US$) of CO2 damage in 1998 and the Cost (current US$) of Energy in 2001?
Your response must be concise. -1.76e+09. What is the difference between the Cost (current US$) in CO2 damage in 1998 and the Cost (current US$) in Forest in 2001?
Offer a very short reply. -1.19e+08. What is the difference between the Cost (current US$) in Minerals in 1998 and the Cost (current US$) in Energy in 2001?
Keep it short and to the point. -2.06e+09. What is the difference between the Cost (current US$) of Minerals in 1998 and the Cost (current US$) of Forest in 2001?
Provide a succinct answer. -4.20e+08. What is the difference between the Cost (current US$) of Energy in 1998 and the Cost (current US$) of Forest in 2001?
Make the answer very short. 1.87e+08. What is the difference between the Cost (current US$) of CO2 damage in 1998 and the Cost (current US$) of Minerals in 2002?
Ensure brevity in your answer.  2.98e+08. What is the difference between the Cost (current US$) of CO2 damage in 1998 and the Cost (current US$) of Energy in 2002?
Provide a short and direct response. -1.49e+09. What is the difference between the Cost (current US$) in CO2 damage in 1998 and the Cost (current US$) in Forest in 2002?
Your response must be concise. -1.34e+08. What is the difference between the Cost (current US$) of Minerals in 1998 and the Cost (current US$) of Energy in 2002?
Keep it short and to the point. -1.79e+09. What is the difference between the Cost (current US$) of Minerals in 1998 and the Cost (current US$) of Forest in 2002?
Offer a terse response. -4.34e+08. What is the difference between the Cost (current US$) in Energy in 1998 and the Cost (current US$) in Forest in 2002?
Ensure brevity in your answer.  1.73e+08. What is the difference between the Cost (current US$) of CO2 damage in 1998 and the Cost (current US$) of Minerals in 2003?
Your response must be concise. 2.97e+08. What is the difference between the Cost (current US$) of CO2 damage in 1998 and the Cost (current US$) of Energy in 2003?
Make the answer very short. -1.91e+09. What is the difference between the Cost (current US$) in CO2 damage in 1998 and the Cost (current US$) in Forest in 2003?
Your answer should be compact. -2.37e+08. What is the difference between the Cost (current US$) of Minerals in 1998 and the Cost (current US$) of Energy in 2003?
Provide a succinct answer. -2.21e+09. What is the difference between the Cost (current US$) of Minerals in 1998 and the Cost (current US$) of Forest in 2003?
Provide a short and direct response. -5.38e+08. What is the difference between the Cost (current US$) in Energy in 1998 and the Cost (current US$) in Forest in 2003?
Ensure brevity in your answer.  6.92e+07. What is the difference between the Cost (current US$) of CO2 damage in 1999 and the Cost (current US$) of Minerals in 2000?
Your response must be concise. 3.09e+08. What is the difference between the Cost (current US$) of CO2 damage in 1999 and the Cost (current US$) of Energy in 2000?
Ensure brevity in your answer.  -1.86e+09. What is the difference between the Cost (current US$) in CO2 damage in 1999 and the Cost (current US$) in Forest in 2000?
Your answer should be compact. -8.94e+07. What is the difference between the Cost (current US$) in Minerals in 1999 and the Cost (current US$) in Energy in 2000?
Give a very brief answer. -2.17e+09. What is the difference between the Cost (current US$) of Minerals in 1999 and the Cost (current US$) of Forest in 2000?
Your answer should be compact. -3.99e+08. What is the difference between the Cost (current US$) in Energy in 1999 and the Cost (current US$) in Forest in 2000?
Your response must be concise. 7.02e+08. What is the difference between the Cost (current US$) of CO2 damage in 1999 and the Cost (current US$) of Minerals in 2001?
Make the answer very short. 3.11e+08. What is the difference between the Cost (current US$) of CO2 damage in 1999 and the Cost (current US$) of Energy in 2001?
Your answer should be very brief. -1.75e+09. What is the difference between the Cost (current US$) of CO2 damage in 1999 and the Cost (current US$) of Forest in 2001?
Your answer should be compact. -1.10e+08. What is the difference between the Cost (current US$) of Minerals in 1999 and the Cost (current US$) of Energy in 2001?
Provide a short and direct response. -2.06e+09. What is the difference between the Cost (current US$) in Minerals in 1999 and the Cost (current US$) in Forest in 2001?
Keep it short and to the point. -4.19e+08. What is the difference between the Cost (current US$) in Energy in 1999 and the Cost (current US$) in Forest in 2001?
Give a very brief answer. 6.82e+08. What is the difference between the Cost (current US$) in CO2 damage in 1999 and the Cost (current US$) in Minerals in 2002?
Keep it short and to the point. 3.08e+08. What is the difference between the Cost (current US$) in CO2 damage in 1999 and the Cost (current US$) in Energy in 2002?
Provide a short and direct response. -1.48e+09. What is the difference between the Cost (current US$) in CO2 damage in 1999 and the Cost (current US$) in Forest in 2002?
Make the answer very short. -1.24e+08. What is the difference between the Cost (current US$) of Minerals in 1999 and the Cost (current US$) of Energy in 2002?
Give a very brief answer. -1.79e+09. What is the difference between the Cost (current US$) of Minerals in 1999 and the Cost (current US$) of Forest in 2002?
Your answer should be compact. -4.34e+08. What is the difference between the Cost (current US$) of Energy in 1999 and the Cost (current US$) of Forest in 2002?
Give a very brief answer. 6.67e+08. What is the difference between the Cost (current US$) of CO2 damage in 1999 and the Cost (current US$) of Minerals in 2003?
Ensure brevity in your answer.  3.06e+08. What is the difference between the Cost (current US$) in CO2 damage in 1999 and the Cost (current US$) in Energy in 2003?
Offer a terse response. -1.90e+09. What is the difference between the Cost (current US$) of CO2 damage in 1999 and the Cost (current US$) of Forest in 2003?
Provide a short and direct response. -2.28e+08. What is the difference between the Cost (current US$) of Minerals in 1999 and the Cost (current US$) of Energy in 2003?
Make the answer very short. -2.21e+09. What is the difference between the Cost (current US$) of Minerals in 1999 and the Cost (current US$) of Forest in 2003?
Give a very brief answer. -5.38e+08. What is the difference between the Cost (current US$) of Energy in 1999 and the Cost (current US$) of Forest in 2003?
Your answer should be compact. 5.64e+08. What is the difference between the Cost (current US$) of CO2 damage in 2000 and the Cost (current US$) of Minerals in 2001?
Ensure brevity in your answer.  3.62e+08. What is the difference between the Cost (current US$) in CO2 damage in 2000 and the Cost (current US$) in Energy in 2001?
Your answer should be compact. -1.70e+09. What is the difference between the Cost (current US$) in CO2 damage in 2000 and the Cost (current US$) in Forest in 2001?
Your answer should be very brief. -5.82e+07. What is the difference between the Cost (current US$) of Minerals in 2000 and the Cost (current US$) of Energy in 2001?
Provide a short and direct response. -2.06e+09. What is the difference between the Cost (current US$) in Minerals in 2000 and the Cost (current US$) in Forest in 2001?
Your response must be concise. -4.19e+08. What is the difference between the Cost (current US$) of Energy in 2000 and the Cost (current US$) of Forest in 2001?
Provide a short and direct response. 1.75e+09. What is the difference between the Cost (current US$) in CO2 damage in 2000 and the Cost (current US$) in Minerals in 2002?
Keep it short and to the point. 3.59e+08. What is the difference between the Cost (current US$) of CO2 damage in 2000 and the Cost (current US$) of Energy in 2002?
Ensure brevity in your answer.  -1.43e+09. What is the difference between the Cost (current US$) in CO2 damage in 2000 and the Cost (current US$) in Forest in 2002?
Provide a short and direct response. -7.28e+07. What is the difference between the Cost (current US$) in Minerals in 2000 and the Cost (current US$) in Energy in 2002?
Provide a short and direct response. -1.79e+09. What is the difference between the Cost (current US$) of Minerals in 2000 and the Cost (current US$) of Forest in 2002?
Your answer should be compact. -4.34e+08. What is the difference between the Cost (current US$) in Energy in 2000 and the Cost (current US$) in Forest in 2002?
Offer a very short reply. 1.73e+09. What is the difference between the Cost (current US$) of CO2 damage in 2000 and the Cost (current US$) of Minerals in 2003?
Provide a succinct answer. 3.57e+08. What is the difference between the Cost (current US$) of CO2 damage in 2000 and the Cost (current US$) of Energy in 2003?
Keep it short and to the point. -1.85e+09. What is the difference between the Cost (current US$) in CO2 damage in 2000 and the Cost (current US$) in Forest in 2003?
Your response must be concise. -1.76e+08. What is the difference between the Cost (current US$) in Minerals in 2000 and the Cost (current US$) in Energy in 2003?
Provide a short and direct response. -2.21e+09. What is the difference between the Cost (current US$) of Minerals in 2000 and the Cost (current US$) of Forest in 2003?
Offer a terse response. -5.37e+08. What is the difference between the Cost (current US$) of Energy in 2000 and the Cost (current US$) of Forest in 2003?
Give a very brief answer. 1.63e+09. What is the difference between the Cost (current US$) of CO2 damage in 2001 and the Cost (current US$) of Minerals in 2002?
Provide a short and direct response. 4.25e+08. What is the difference between the Cost (current US$) of CO2 damage in 2001 and the Cost (current US$) of Energy in 2002?
Your answer should be very brief. -1.36e+09. What is the difference between the Cost (current US$) in CO2 damage in 2001 and the Cost (current US$) in Forest in 2002?
Keep it short and to the point. -7.23e+06. What is the difference between the Cost (current US$) of Minerals in 2001 and the Cost (current US$) of Energy in 2002?
Your response must be concise. -1.79e+09. What is the difference between the Cost (current US$) of Minerals in 2001 and the Cost (current US$) of Forest in 2002?
Your answer should be very brief. -4.35e+08. What is the difference between the Cost (current US$) in Energy in 2001 and the Cost (current US$) in Forest in 2002?
Provide a short and direct response. 1.63e+09. What is the difference between the Cost (current US$) of CO2 damage in 2001 and the Cost (current US$) of Minerals in 2003?
Keep it short and to the point. 4.23e+08. What is the difference between the Cost (current US$) in CO2 damage in 2001 and the Cost (current US$) in Energy in 2003?
Your response must be concise. -1.78e+09. What is the difference between the Cost (current US$) in CO2 damage in 2001 and the Cost (current US$) in Forest in 2003?
Make the answer very short. -1.11e+08. What is the difference between the Cost (current US$) in Minerals in 2001 and the Cost (current US$) in Energy in 2003?
Your response must be concise. -2.21e+09. What is the difference between the Cost (current US$) in Minerals in 2001 and the Cost (current US$) in Forest in 2003?
Offer a very short reply. -5.39e+08. What is the difference between the Cost (current US$) in Energy in 2001 and the Cost (current US$) in Forest in 2003?
Make the answer very short. 1.52e+09. What is the difference between the Cost (current US$) of CO2 damage in 2002 and the Cost (current US$) of Minerals in 2003?
Give a very brief answer. 5.05e+08. What is the difference between the Cost (current US$) in CO2 damage in 2002 and the Cost (current US$) in Energy in 2003?
Offer a very short reply. -1.70e+09. What is the difference between the Cost (current US$) in CO2 damage in 2002 and the Cost (current US$) in Forest in 2003?
Keep it short and to the point. -2.90e+07. What is the difference between the Cost (current US$) in Minerals in 2002 and the Cost (current US$) in Energy in 2003?
Keep it short and to the point. -2.21e+09. What is the difference between the Cost (current US$) in Minerals in 2002 and the Cost (current US$) in Forest in 2003?
Your answer should be very brief. -5.36e+08. What is the difference between the Cost (current US$) of Energy in 2002 and the Cost (current US$) of Forest in 2003?
Provide a succinct answer. 1.25e+09. What is the average Cost (current US$) of CO2 damage per year?
Make the answer very short. 3.53e+08. What is the average Cost (current US$) in Minerals per year?
Give a very brief answer. 4.52e+06. What is the average Cost (current US$) of Energy per year?
Ensure brevity in your answer.  1.38e+09. What is the average Cost (current US$) in Forest per year?
Your answer should be very brief. 5.81e+08. In the year 1995, what is the difference between the Cost (current US$) of CO2 damage and Cost (current US$) of Minerals?
Your response must be concise. 1.70e+08. In the year 1995, what is the difference between the Cost (current US$) of CO2 damage and Cost (current US$) of Energy?
Offer a terse response. -5.43e+08. In the year 1995, what is the difference between the Cost (current US$) of CO2 damage and Cost (current US$) of Forest?
Give a very brief answer. -6.02e+08. In the year 1995, what is the difference between the Cost (current US$) of Minerals and Cost (current US$) of Energy?
Offer a very short reply. -7.12e+08. In the year 1995, what is the difference between the Cost (current US$) of Minerals and Cost (current US$) of Forest?
Ensure brevity in your answer.  -7.71e+08. In the year 1995, what is the difference between the Cost (current US$) of Energy and Cost (current US$) of Forest?
Your answer should be very brief. -5.90e+07. In the year 1996, what is the difference between the Cost (current US$) of CO2 damage and Cost (current US$) of Minerals?
Keep it short and to the point. 2.09e+08. In the year 1996, what is the difference between the Cost (current US$) in CO2 damage and Cost (current US$) in Energy?
Offer a very short reply. -6.68e+08. In the year 1996, what is the difference between the Cost (current US$) in CO2 damage and Cost (current US$) in Forest?
Your response must be concise. -6.85e+08. In the year 1996, what is the difference between the Cost (current US$) of Minerals and Cost (current US$) of Energy?
Your answer should be compact. -8.77e+08. In the year 1996, what is the difference between the Cost (current US$) in Minerals and Cost (current US$) in Forest?
Provide a succinct answer. -8.94e+08. In the year 1996, what is the difference between the Cost (current US$) of Energy and Cost (current US$) of Forest?
Make the answer very short. -1.73e+07. In the year 1997, what is the difference between the Cost (current US$) in CO2 damage and Cost (current US$) in Minerals?
Your answer should be compact. 2.76e+08. In the year 1997, what is the difference between the Cost (current US$) of CO2 damage and Cost (current US$) of Energy?
Give a very brief answer. -5.52e+08. In the year 1997, what is the difference between the Cost (current US$) in CO2 damage and Cost (current US$) in Forest?
Provide a short and direct response. -4.68e+08. In the year 1997, what is the difference between the Cost (current US$) of Minerals and Cost (current US$) of Energy?
Keep it short and to the point. -8.28e+08. In the year 1997, what is the difference between the Cost (current US$) of Minerals and Cost (current US$) of Forest?
Your response must be concise. -7.44e+08. In the year 1997, what is the difference between the Cost (current US$) in Energy and Cost (current US$) in Forest?
Provide a short and direct response. 8.39e+07. In the year 1998, what is the difference between the Cost (current US$) in CO2 damage and Cost (current US$) in Minerals?
Provide a succinct answer. 3.01e+08. In the year 1998, what is the difference between the Cost (current US$) in CO2 damage and Cost (current US$) in Energy?
Provide a short and direct response. -3.06e+08. In the year 1998, what is the difference between the Cost (current US$) in CO2 damage and Cost (current US$) in Forest?
Provide a succinct answer. -3.33e+08. In the year 1998, what is the difference between the Cost (current US$) of Minerals and Cost (current US$) of Energy?
Make the answer very short. -6.07e+08. In the year 1998, what is the difference between the Cost (current US$) of Minerals and Cost (current US$) of Forest?
Offer a very short reply. -6.34e+08. In the year 1998, what is the difference between the Cost (current US$) in Energy and Cost (current US$) in Forest?
Provide a succinct answer. -2.70e+07. In the year 1999, what is the difference between the Cost (current US$) in CO2 damage and Cost (current US$) in Minerals?
Make the answer very short. 3.10e+08. In the year 1999, what is the difference between the Cost (current US$) in CO2 damage and Cost (current US$) in Energy?
Offer a very short reply. -7.91e+08. In the year 1999, what is the difference between the Cost (current US$) in CO2 damage and Cost (current US$) in Forest?
Offer a terse response. -5.25e+07. In the year 1999, what is the difference between the Cost (current US$) of Minerals and Cost (current US$) of Energy?
Your answer should be very brief. -1.10e+09. In the year 1999, what is the difference between the Cost (current US$) in Minerals and Cost (current US$) in Forest?
Keep it short and to the point. -3.62e+08. In the year 1999, what is the difference between the Cost (current US$) of Energy and Cost (current US$) of Forest?
Keep it short and to the point. 7.39e+08. In the year 2000, what is the difference between the Cost (current US$) in CO2 damage and Cost (current US$) in Minerals?
Offer a terse response. 3.61e+08. In the year 2000, what is the difference between the Cost (current US$) in CO2 damage and Cost (current US$) in Energy?
Ensure brevity in your answer.  -1.81e+09. In the year 2000, what is the difference between the Cost (current US$) of CO2 damage and Cost (current US$) of Forest?
Your answer should be very brief. -3.79e+07. In the year 2000, what is the difference between the Cost (current US$) of Minerals and Cost (current US$) of Energy?
Ensure brevity in your answer.  -2.17e+09. In the year 2000, what is the difference between the Cost (current US$) in Minerals and Cost (current US$) in Forest?
Keep it short and to the point. -3.99e+08. In the year 2000, what is the difference between the Cost (current US$) of Energy and Cost (current US$) of Forest?
Give a very brief answer. 1.77e+09. In the year 2001, what is the difference between the Cost (current US$) in CO2 damage and Cost (current US$) in Minerals?
Provide a short and direct response. 4.28e+08. In the year 2001, what is the difference between the Cost (current US$) in CO2 damage and Cost (current US$) in Energy?
Give a very brief answer. -1.63e+09. In the year 2001, what is the difference between the Cost (current US$) in CO2 damage and Cost (current US$) in Forest?
Your answer should be compact. 7.34e+06. In the year 2001, what is the difference between the Cost (current US$) in Minerals and Cost (current US$) in Energy?
Give a very brief answer. -2.06e+09. In the year 2001, what is the difference between the Cost (current US$) in Minerals and Cost (current US$) in Forest?
Make the answer very short. -4.21e+08. In the year 2001, what is the difference between the Cost (current US$) in Energy and Cost (current US$) in Forest?
Offer a very short reply. 1.64e+09. In the year 2002, what is the difference between the Cost (current US$) in CO2 damage and Cost (current US$) in Minerals?
Offer a terse response. 5.07e+08. In the year 2002, what is the difference between the Cost (current US$) in CO2 damage and Cost (current US$) in Energy?
Make the answer very short. -1.28e+09. In the year 2002, what is the difference between the Cost (current US$) in CO2 damage and Cost (current US$) in Forest?
Your response must be concise. 7.45e+07. In the year 2002, what is the difference between the Cost (current US$) in Minerals and Cost (current US$) in Energy?
Make the answer very short. -1.79e+09. In the year 2002, what is the difference between the Cost (current US$) in Minerals and Cost (current US$) in Forest?
Your answer should be very brief. -4.32e+08. In the year 2002, what is the difference between the Cost (current US$) of Energy and Cost (current US$) of Forest?
Offer a very short reply. 1.36e+09. In the year 2003, what is the difference between the Cost (current US$) in CO2 damage and Cost (current US$) in Minerals?
Your answer should be compact. 5.81e+08. In the year 2003, what is the difference between the Cost (current US$) in CO2 damage and Cost (current US$) in Energy?
Offer a terse response. -1.62e+09. In the year 2003, what is the difference between the Cost (current US$) of CO2 damage and Cost (current US$) of Forest?
Keep it short and to the point. 4.69e+07. In the year 2003, what is the difference between the Cost (current US$) in Minerals and Cost (current US$) in Energy?
Provide a succinct answer. -2.20e+09. In the year 2003, what is the difference between the Cost (current US$) in Minerals and Cost (current US$) in Forest?
Your answer should be very brief. -5.34e+08. In the year 2003, what is the difference between the Cost (current US$) of Energy and Cost (current US$) of Forest?
Your response must be concise. 1.67e+09. What is the ratio of the Cost (current US$) in CO2 damage in 1995 to that in 1996?
Your answer should be compact. 0.81. What is the ratio of the Cost (current US$) of Minerals in 1995 to that in 1996?
Your answer should be compact. 0.86. What is the ratio of the Cost (current US$) in Energy in 1995 to that in 1996?
Keep it short and to the point. 0.81. What is the ratio of the Cost (current US$) in Forest in 1995 to that in 1996?
Offer a very short reply. 0.86. What is the ratio of the Cost (current US$) in CO2 damage in 1995 to that in 1997?
Offer a terse response. 0.61. What is the ratio of the Cost (current US$) in Minerals in 1995 to that in 1997?
Your response must be concise. 0.29. What is the ratio of the Cost (current US$) of Energy in 1995 to that in 1997?
Keep it short and to the point. 0.86. What is the ratio of the Cost (current US$) in Forest in 1995 to that in 1997?
Provide a short and direct response. 1.03. What is the ratio of the Cost (current US$) in CO2 damage in 1995 to that in 1998?
Your answer should be very brief. 0.56. What is the ratio of the Cost (current US$) in Minerals in 1995 to that in 1998?
Keep it short and to the point. 0.55. What is the ratio of the Cost (current US$) of Energy in 1995 to that in 1998?
Your response must be concise. 1.17. What is the ratio of the Cost (current US$) in Forest in 1995 to that in 1998?
Provide a short and direct response. 1.21. What is the ratio of the Cost (current US$) in CO2 damage in 1995 to that in 1999?
Your response must be concise. 0.55. What is the ratio of the Cost (current US$) in Minerals in 1995 to that in 1999?
Provide a succinct answer. 0.49. What is the ratio of the Cost (current US$) of Energy in 1995 to that in 1999?
Your answer should be very brief. 0.65. What is the ratio of the Cost (current US$) in Forest in 1995 to that in 1999?
Ensure brevity in your answer.  2.11. What is the ratio of the Cost (current US$) of CO2 damage in 1995 to that in 2000?
Make the answer very short. 0.47. What is the ratio of the Cost (current US$) of Minerals in 1995 to that in 2000?
Your answer should be very brief. 0.44. What is the ratio of the Cost (current US$) of Energy in 1995 to that in 2000?
Your answer should be very brief. 0.33. What is the ratio of the Cost (current US$) of Forest in 1995 to that in 2000?
Your response must be concise. 1.92. What is the ratio of the Cost (current US$) in CO2 damage in 1995 to that in 2001?
Offer a terse response. 0.4. What is the ratio of the Cost (current US$) of Minerals in 1995 to that in 2001?
Offer a terse response. 0.66. What is the ratio of the Cost (current US$) of Energy in 1995 to that in 2001?
Your response must be concise. 0.35. What is the ratio of the Cost (current US$) of Forest in 1995 to that in 2001?
Offer a very short reply. 1.83. What is the ratio of the Cost (current US$) in CO2 damage in 1995 to that in 2002?
Offer a terse response. 0.34. What is the ratio of the Cost (current US$) of Minerals in 1995 to that in 2002?
Offer a terse response. 0.33. What is the ratio of the Cost (current US$) in Energy in 1995 to that in 2002?
Your answer should be compact. 0.4. What is the ratio of the Cost (current US$) in Forest in 1995 to that in 2002?
Ensure brevity in your answer.  1.77. What is the ratio of the Cost (current US$) in CO2 damage in 1995 to that in 2003?
Keep it short and to the point. 0.29. What is the ratio of the Cost (current US$) in Minerals in 1995 to that in 2003?
Make the answer very short. 0.26. What is the ratio of the Cost (current US$) of Energy in 1995 to that in 2003?
Provide a succinct answer. 0.32. What is the ratio of the Cost (current US$) in Forest in 1995 to that in 2003?
Make the answer very short. 1.43. What is the ratio of the Cost (current US$) in CO2 damage in 1996 to that in 1997?
Provide a short and direct response. 0.75. What is the ratio of the Cost (current US$) in Minerals in 1996 to that in 1997?
Keep it short and to the point. 0.34. What is the ratio of the Cost (current US$) of Energy in 1996 to that in 1997?
Make the answer very short. 1.05. What is the ratio of the Cost (current US$) of Forest in 1996 to that in 1997?
Provide a succinct answer. 1.19. What is the ratio of the Cost (current US$) of CO2 damage in 1996 to that in 1998?
Your response must be concise. 0.69. What is the ratio of the Cost (current US$) of Minerals in 1996 to that in 1998?
Offer a very short reply. 0.64. What is the ratio of the Cost (current US$) of Energy in 1996 to that in 1998?
Your response must be concise. 1.44. What is the ratio of the Cost (current US$) in Forest in 1996 to that in 1998?
Give a very brief answer. 1.41. What is the ratio of the Cost (current US$) of CO2 damage in 1996 to that in 1999?
Provide a succinct answer. 0.67. What is the ratio of the Cost (current US$) in Minerals in 1996 to that in 1999?
Your response must be concise. 0.57. What is the ratio of the Cost (current US$) in Energy in 1996 to that in 1999?
Offer a terse response. 0.8. What is the ratio of the Cost (current US$) of Forest in 1996 to that in 1999?
Your answer should be compact. 2.45. What is the ratio of the Cost (current US$) in CO2 damage in 1996 to that in 2000?
Your answer should be very brief. 0.58. What is the ratio of the Cost (current US$) of Minerals in 1996 to that in 2000?
Offer a very short reply. 0.51. What is the ratio of the Cost (current US$) in Energy in 1996 to that in 2000?
Your answer should be compact. 0.4. What is the ratio of the Cost (current US$) in Forest in 1996 to that in 2000?
Make the answer very short. 2.22. What is the ratio of the Cost (current US$) in CO2 damage in 1996 to that in 2001?
Your answer should be very brief. 0.49. What is the ratio of the Cost (current US$) of Minerals in 1996 to that in 2001?
Your answer should be very brief. 0.77. What is the ratio of the Cost (current US$) of Energy in 1996 to that in 2001?
Your answer should be compact. 0.43. What is the ratio of the Cost (current US$) in Forest in 1996 to that in 2001?
Your answer should be compact. 2.12. What is the ratio of the Cost (current US$) in CO2 damage in 1996 to that in 2002?
Give a very brief answer. 0.41. What is the ratio of the Cost (current US$) in Minerals in 1996 to that in 2002?
Offer a terse response. 0.39. What is the ratio of the Cost (current US$) of Energy in 1996 to that in 2002?
Give a very brief answer. 0.49. What is the ratio of the Cost (current US$) in Forest in 1996 to that in 2002?
Ensure brevity in your answer.  2.05. What is the ratio of the Cost (current US$) in CO2 damage in 1996 to that in 2003?
Provide a succinct answer. 0.36. What is the ratio of the Cost (current US$) of Minerals in 1996 to that in 2003?
Your response must be concise. 0.3. What is the ratio of the Cost (current US$) in Energy in 1996 to that in 2003?
Make the answer very short. 0.4. What is the ratio of the Cost (current US$) in Forest in 1996 to that in 2003?
Your response must be concise. 1.66. What is the ratio of the Cost (current US$) of CO2 damage in 1997 to that in 1998?
Your answer should be compact. 0.93. What is the ratio of the Cost (current US$) in Minerals in 1997 to that in 1998?
Offer a terse response. 1.86. What is the ratio of the Cost (current US$) of Energy in 1997 to that in 1998?
Your answer should be compact. 1.37. What is the ratio of the Cost (current US$) in Forest in 1997 to that in 1998?
Make the answer very short. 1.18. What is the ratio of the Cost (current US$) of CO2 damage in 1997 to that in 1999?
Your response must be concise. 0.9. What is the ratio of the Cost (current US$) in Minerals in 1997 to that in 1999?
Offer a very short reply. 1.66. What is the ratio of the Cost (current US$) in Energy in 1997 to that in 1999?
Your response must be concise. 0.76. What is the ratio of the Cost (current US$) in Forest in 1997 to that in 1999?
Ensure brevity in your answer.  2.05. What is the ratio of the Cost (current US$) in CO2 damage in 1997 to that in 2000?
Provide a succinct answer. 0.77. What is the ratio of the Cost (current US$) of Minerals in 1997 to that in 2000?
Your answer should be very brief. 1.49. What is the ratio of the Cost (current US$) in Energy in 1997 to that in 2000?
Keep it short and to the point. 0.38. What is the ratio of the Cost (current US$) of Forest in 1997 to that in 2000?
Ensure brevity in your answer.  1.86. What is the ratio of the Cost (current US$) in CO2 damage in 1997 to that in 2001?
Your answer should be very brief. 0.66. What is the ratio of the Cost (current US$) of Minerals in 1997 to that in 2001?
Your answer should be very brief. 2.25. What is the ratio of the Cost (current US$) in Energy in 1997 to that in 2001?
Your answer should be very brief. 0.4. What is the ratio of the Cost (current US$) in Forest in 1997 to that in 2001?
Keep it short and to the point. 1.77. What is the ratio of the Cost (current US$) in CO2 damage in 1997 to that in 2002?
Offer a very short reply. 0.55. What is the ratio of the Cost (current US$) of Minerals in 1997 to that in 2002?
Offer a very short reply. 1.12. What is the ratio of the Cost (current US$) in Energy in 1997 to that in 2002?
Your response must be concise. 0.46. What is the ratio of the Cost (current US$) in Forest in 1997 to that in 2002?
Your answer should be compact. 1.71. What is the ratio of the Cost (current US$) in CO2 damage in 1997 to that in 2003?
Provide a short and direct response. 0.48. What is the ratio of the Cost (current US$) in Minerals in 1997 to that in 2003?
Keep it short and to the point. 0.87. What is the ratio of the Cost (current US$) of Energy in 1997 to that in 2003?
Make the answer very short. 0.38. What is the ratio of the Cost (current US$) of Forest in 1997 to that in 2003?
Make the answer very short. 1.39. What is the ratio of the Cost (current US$) in CO2 damage in 1998 to that in 1999?
Your answer should be compact. 0.97. What is the ratio of the Cost (current US$) in Minerals in 1998 to that in 1999?
Your answer should be very brief. 0.89. What is the ratio of the Cost (current US$) of Energy in 1998 to that in 1999?
Ensure brevity in your answer.  0.55. What is the ratio of the Cost (current US$) of Forest in 1998 to that in 1999?
Make the answer very short. 1.74. What is the ratio of the Cost (current US$) of CO2 damage in 1998 to that in 2000?
Provide a short and direct response. 0.83. What is the ratio of the Cost (current US$) in Minerals in 1998 to that in 2000?
Ensure brevity in your answer.  0.8. What is the ratio of the Cost (current US$) in Energy in 1998 to that in 2000?
Give a very brief answer. 0.28. What is the ratio of the Cost (current US$) of Forest in 1998 to that in 2000?
Your answer should be compact. 1.58. What is the ratio of the Cost (current US$) of CO2 damage in 1998 to that in 2001?
Offer a very short reply. 0.71. What is the ratio of the Cost (current US$) in Minerals in 1998 to that in 2001?
Your answer should be very brief. 1.21. What is the ratio of the Cost (current US$) in Energy in 1998 to that in 2001?
Your answer should be compact. 0.3. What is the ratio of the Cost (current US$) in Forest in 1998 to that in 2001?
Provide a short and direct response. 1.51. What is the ratio of the Cost (current US$) of CO2 damage in 1998 to that in 2002?
Offer a very short reply. 0.59. What is the ratio of the Cost (current US$) in Minerals in 1998 to that in 2002?
Your answer should be compact. 0.6. What is the ratio of the Cost (current US$) of Energy in 1998 to that in 2002?
Your answer should be very brief. 0.34. What is the ratio of the Cost (current US$) in Forest in 1998 to that in 2002?
Provide a succinct answer. 1.46. What is the ratio of the Cost (current US$) in CO2 damage in 1998 to that in 2003?
Keep it short and to the point. 0.52. What is the ratio of the Cost (current US$) in Minerals in 1998 to that in 2003?
Your answer should be very brief. 0.47. What is the ratio of the Cost (current US$) of Energy in 1998 to that in 2003?
Your answer should be very brief. 0.28. What is the ratio of the Cost (current US$) in Forest in 1998 to that in 2003?
Offer a very short reply. 1.18. What is the ratio of the Cost (current US$) in CO2 damage in 1999 to that in 2000?
Your response must be concise. 0.86. What is the ratio of the Cost (current US$) of Minerals in 1999 to that in 2000?
Offer a terse response. 0.9. What is the ratio of the Cost (current US$) of Energy in 1999 to that in 2000?
Give a very brief answer. 0.51. What is the ratio of the Cost (current US$) in Forest in 1999 to that in 2000?
Your response must be concise. 0.91. What is the ratio of the Cost (current US$) in CO2 damage in 1999 to that in 2001?
Your response must be concise. 0.73. What is the ratio of the Cost (current US$) of Minerals in 1999 to that in 2001?
Make the answer very short. 1.36. What is the ratio of the Cost (current US$) of Energy in 1999 to that in 2001?
Give a very brief answer. 0.54. What is the ratio of the Cost (current US$) of Forest in 1999 to that in 2001?
Provide a short and direct response. 0.87. What is the ratio of the Cost (current US$) in CO2 damage in 1999 to that in 2002?
Keep it short and to the point. 0.61. What is the ratio of the Cost (current US$) of Minerals in 1999 to that in 2002?
Offer a very short reply. 0.68. What is the ratio of the Cost (current US$) of Energy in 1999 to that in 2002?
Provide a short and direct response. 0.62. What is the ratio of the Cost (current US$) of Forest in 1999 to that in 2002?
Offer a terse response. 0.84. What is the ratio of the Cost (current US$) in CO2 damage in 1999 to that in 2003?
Your answer should be very brief. 0.53. What is the ratio of the Cost (current US$) of Minerals in 1999 to that in 2003?
Keep it short and to the point. 0.52. What is the ratio of the Cost (current US$) in Energy in 1999 to that in 2003?
Keep it short and to the point. 0.5. What is the ratio of the Cost (current US$) of Forest in 1999 to that in 2003?
Keep it short and to the point. 0.68. What is the ratio of the Cost (current US$) of CO2 damage in 2000 to that in 2001?
Give a very brief answer. 0.85. What is the ratio of the Cost (current US$) in Minerals in 2000 to that in 2001?
Provide a short and direct response. 1.51. What is the ratio of the Cost (current US$) in Energy in 2000 to that in 2001?
Ensure brevity in your answer.  1.05. What is the ratio of the Cost (current US$) in Forest in 2000 to that in 2001?
Your response must be concise. 0.95. What is the ratio of the Cost (current US$) of CO2 damage in 2000 to that in 2002?
Your response must be concise. 0.71. What is the ratio of the Cost (current US$) in Minerals in 2000 to that in 2002?
Your response must be concise. 0.76. What is the ratio of the Cost (current US$) of Energy in 2000 to that in 2002?
Your answer should be compact. 1.21. What is the ratio of the Cost (current US$) of Forest in 2000 to that in 2002?
Your response must be concise. 0.92. What is the ratio of the Cost (current US$) of CO2 damage in 2000 to that in 2003?
Provide a short and direct response. 0.62. What is the ratio of the Cost (current US$) of Minerals in 2000 to that in 2003?
Provide a short and direct response. 0.58. What is the ratio of the Cost (current US$) in Energy in 2000 to that in 2003?
Your answer should be very brief. 0.98. What is the ratio of the Cost (current US$) of Forest in 2000 to that in 2003?
Offer a terse response. 0.74. What is the ratio of the Cost (current US$) in CO2 damage in 2001 to that in 2002?
Make the answer very short. 0.84. What is the ratio of the Cost (current US$) in Minerals in 2001 to that in 2002?
Provide a short and direct response. 0.5. What is the ratio of the Cost (current US$) in Energy in 2001 to that in 2002?
Your answer should be compact. 1.15. What is the ratio of the Cost (current US$) of Forest in 2001 to that in 2002?
Your answer should be very brief. 0.97. What is the ratio of the Cost (current US$) of CO2 damage in 2001 to that in 2003?
Your response must be concise. 0.73. What is the ratio of the Cost (current US$) of Minerals in 2001 to that in 2003?
Provide a short and direct response. 0.39. What is the ratio of the Cost (current US$) of Energy in 2001 to that in 2003?
Provide a succinct answer. 0.93. What is the ratio of the Cost (current US$) in Forest in 2001 to that in 2003?
Your answer should be compact. 0.78. What is the ratio of the Cost (current US$) in CO2 damage in 2002 to that in 2003?
Offer a terse response. 0.87. What is the ratio of the Cost (current US$) in Minerals in 2002 to that in 2003?
Your answer should be very brief. 0.77. What is the ratio of the Cost (current US$) of Energy in 2002 to that in 2003?
Ensure brevity in your answer.  0.81. What is the ratio of the Cost (current US$) in Forest in 2002 to that in 2003?
Offer a very short reply. 0.81. What is the difference between the highest and the second highest Cost (current US$) in CO2 damage?
Offer a very short reply. 7.58e+07. What is the difference between the highest and the second highest Cost (current US$) in Minerals?
Keep it short and to the point. 1.02e+06. What is the difference between the highest and the second highest Cost (current US$) of Energy?
Your answer should be compact. 3.87e+07. What is the difference between the highest and the second highest Cost (current US$) in Forest?
Your answer should be compact. 1.23e+08. What is the difference between the highest and the lowest Cost (current US$) in CO2 damage?
Give a very brief answer. 4.17e+08. What is the difference between the highest and the lowest Cost (current US$) in Minerals?
Your answer should be very brief. 5.86e+06. What is the difference between the highest and the lowest Cost (current US$) of Energy?
Provide a succinct answer. 1.60e+09. What is the difference between the highest and the lowest Cost (current US$) in Forest?
Provide a short and direct response. 5.30e+08. 